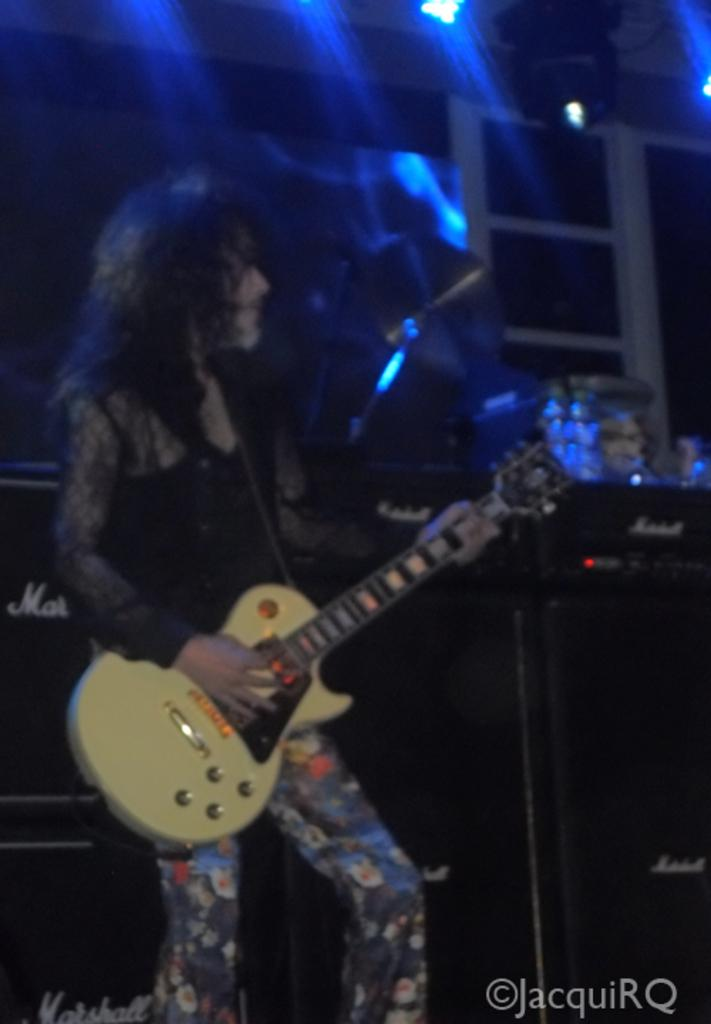What is the person in the image doing? The person is standing in the image and holding a musical instrument. What is the person wearing in the image? The person is wearing a black color shirt. What can be seen in the background of the image? There are lights visible in the background of the image. What type of scale is the person using to weigh the musical instrument in the image? There is no scale present in the image, and the person is not weighing the musical instrument. 